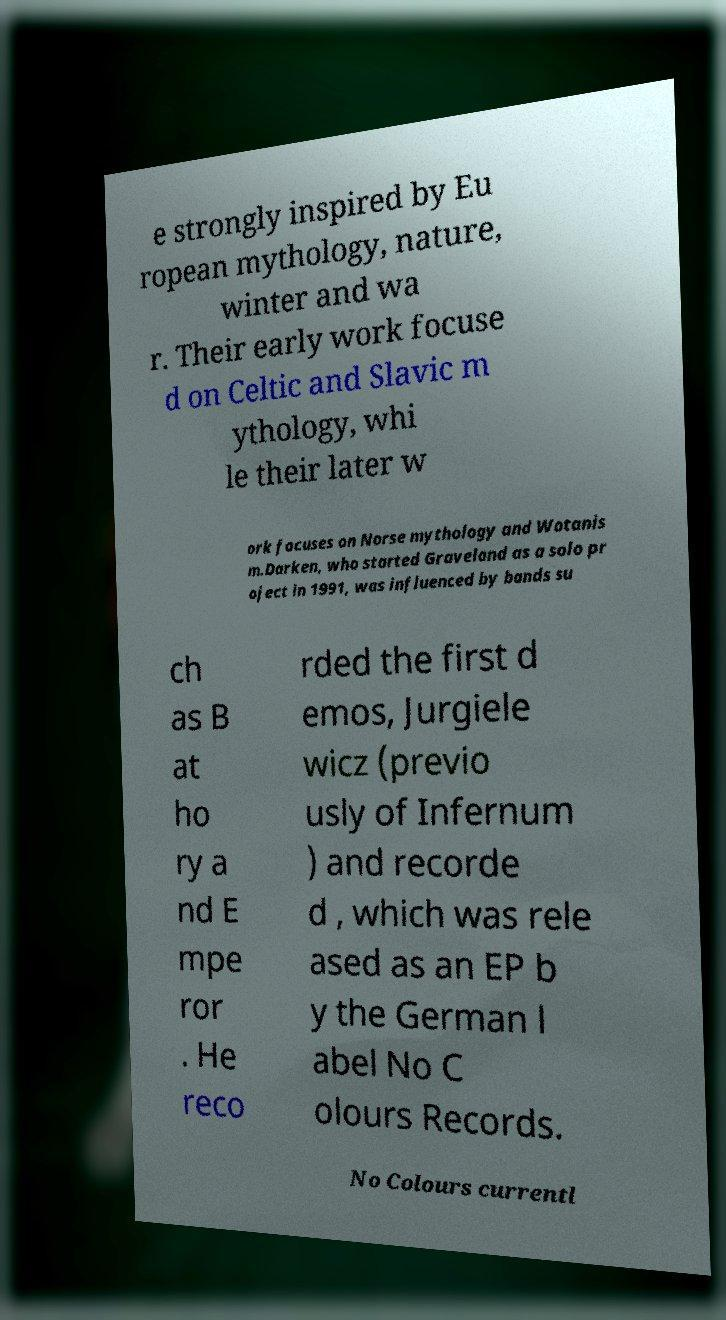Can you accurately transcribe the text from the provided image for me? e strongly inspired by Eu ropean mythology, nature, winter and wa r. Their early work focuse d on Celtic and Slavic m ythology, whi le their later w ork focuses on Norse mythology and Wotanis m.Darken, who started Graveland as a solo pr oject in 1991, was influenced by bands su ch as B at ho ry a nd E mpe ror . He reco rded the first d emos, Jurgiele wicz (previo usly of Infernum ) and recorde d , which was rele ased as an EP b y the German l abel No C olours Records. No Colours currentl 